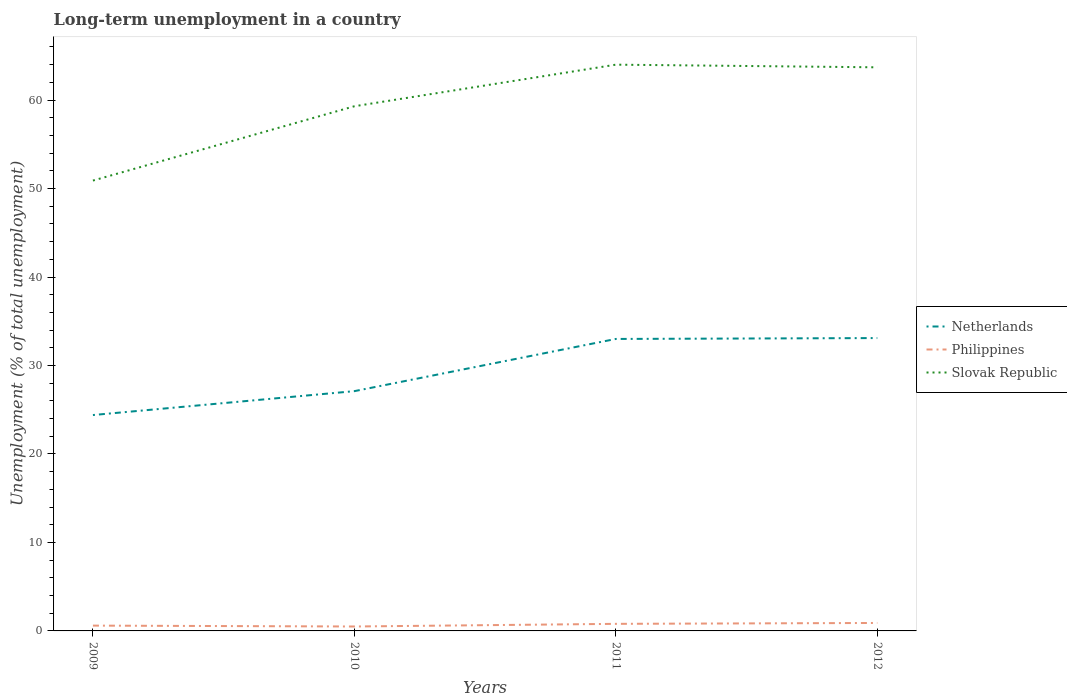How many different coloured lines are there?
Provide a succinct answer. 3. Across all years, what is the maximum percentage of long-term unemployed population in Philippines?
Your response must be concise. 0.5. In which year was the percentage of long-term unemployed population in Slovak Republic maximum?
Keep it short and to the point. 2009. What is the total percentage of long-term unemployed population in Netherlands in the graph?
Ensure brevity in your answer.  -0.1. What is the difference between the highest and the second highest percentage of long-term unemployed population in Philippines?
Your response must be concise. 0.4. How many lines are there?
Provide a short and direct response. 3. How many years are there in the graph?
Offer a very short reply. 4. Are the values on the major ticks of Y-axis written in scientific E-notation?
Your answer should be very brief. No. Does the graph contain grids?
Provide a short and direct response. No. Where does the legend appear in the graph?
Keep it short and to the point. Center right. How many legend labels are there?
Provide a short and direct response. 3. What is the title of the graph?
Give a very brief answer. Long-term unemployment in a country. What is the label or title of the Y-axis?
Offer a very short reply. Unemployment (% of total unemployment). What is the Unemployment (% of total unemployment) of Netherlands in 2009?
Provide a short and direct response. 24.4. What is the Unemployment (% of total unemployment) in Philippines in 2009?
Your response must be concise. 0.6. What is the Unemployment (% of total unemployment) of Slovak Republic in 2009?
Provide a short and direct response. 50.9. What is the Unemployment (% of total unemployment) in Netherlands in 2010?
Your response must be concise. 27.1. What is the Unemployment (% of total unemployment) in Slovak Republic in 2010?
Your answer should be very brief. 59.3. What is the Unemployment (% of total unemployment) of Netherlands in 2011?
Ensure brevity in your answer.  33. What is the Unemployment (% of total unemployment) in Philippines in 2011?
Provide a short and direct response. 0.8. What is the Unemployment (% of total unemployment) in Netherlands in 2012?
Your response must be concise. 33.1. What is the Unemployment (% of total unemployment) in Philippines in 2012?
Offer a terse response. 0.9. What is the Unemployment (% of total unemployment) in Slovak Republic in 2012?
Make the answer very short. 63.7. Across all years, what is the maximum Unemployment (% of total unemployment) of Netherlands?
Provide a succinct answer. 33.1. Across all years, what is the maximum Unemployment (% of total unemployment) of Philippines?
Your response must be concise. 0.9. Across all years, what is the maximum Unemployment (% of total unemployment) in Slovak Republic?
Ensure brevity in your answer.  64. Across all years, what is the minimum Unemployment (% of total unemployment) in Netherlands?
Make the answer very short. 24.4. Across all years, what is the minimum Unemployment (% of total unemployment) of Philippines?
Give a very brief answer. 0.5. Across all years, what is the minimum Unemployment (% of total unemployment) in Slovak Republic?
Ensure brevity in your answer.  50.9. What is the total Unemployment (% of total unemployment) of Netherlands in the graph?
Keep it short and to the point. 117.6. What is the total Unemployment (% of total unemployment) of Philippines in the graph?
Your response must be concise. 2.8. What is the total Unemployment (% of total unemployment) of Slovak Republic in the graph?
Your response must be concise. 237.9. What is the difference between the Unemployment (% of total unemployment) in Netherlands in 2009 and that in 2010?
Offer a terse response. -2.7. What is the difference between the Unemployment (% of total unemployment) in Philippines in 2009 and that in 2011?
Give a very brief answer. -0.2. What is the difference between the Unemployment (% of total unemployment) in Netherlands in 2009 and that in 2012?
Give a very brief answer. -8.7. What is the difference between the Unemployment (% of total unemployment) of Philippines in 2009 and that in 2012?
Provide a short and direct response. -0.3. What is the difference between the Unemployment (% of total unemployment) in Netherlands in 2010 and that in 2011?
Keep it short and to the point. -5.9. What is the difference between the Unemployment (% of total unemployment) in Philippines in 2010 and that in 2011?
Give a very brief answer. -0.3. What is the difference between the Unemployment (% of total unemployment) in Netherlands in 2010 and that in 2012?
Provide a short and direct response. -6. What is the difference between the Unemployment (% of total unemployment) in Netherlands in 2011 and that in 2012?
Offer a terse response. -0.1. What is the difference between the Unemployment (% of total unemployment) of Slovak Republic in 2011 and that in 2012?
Your response must be concise. 0.3. What is the difference between the Unemployment (% of total unemployment) of Netherlands in 2009 and the Unemployment (% of total unemployment) of Philippines in 2010?
Make the answer very short. 23.9. What is the difference between the Unemployment (% of total unemployment) in Netherlands in 2009 and the Unemployment (% of total unemployment) in Slovak Republic in 2010?
Provide a short and direct response. -34.9. What is the difference between the Unemployment (% of total unemployment) in Philippines in 2009 and the Unemployment (% of total unemployment) in Slovak Republic in 2010?
Make the answer very short. -58.7. What is the difference between the Unemployment (% of total unemployment) in Netherlands in 2009 and the Unemployment (% of total unemployment) in Philippines in 2011?
Your answer should be compact. 23.6. What is the difference between the Unemployment (% of total unemployment) in Netherlands in 2009 and the Unemployment (% of total unemployment) in Slovak Republic in 2011?
Your answer should be compact. -39.6. What is the difference between the Unemployment (% of total unemployment) in Philippines in 2009 and the Unemployment (% of total unemployment) in Slovak Republic in 2011?
Provide a succinct answer. -63.4. What is the difference between the Unemployment (% of total unemployment) in Netherlands in 2009 and the Unemployment (% of total unemployment) in Slovak Republic in 2012?
Offer a very short reply. -39.3. What is the difference between the Unemployment (% of total unemployment) of Philippines in 2009 and the Unemployment (% of total unemployment) of Slovak Republic in 2012?
Ensure brevity in your answer.  -63.1. What is the difference between the Unemployment (% of total unemployment) in Netherlands in 2010 and the Unemployment (% of total unemployment) in Philippines in 2011?
Keep it short and to the point. 26.3. What is the difference between the Unemployment (% of total unemployment) in Netherlands in 2010 and the Unemployment (% of total unemployment) in Slovak Republic in 2011?
Offer a terse response. -36.9. What is the difference between the Unemployment (% of total unemployment) in Philippines in 2010 and the Unemployment (% of total unemployment) in Slovak Republic in 2011?
Make the answer very short. -63.5. What is the difference between the Unemployment (% of total unemployment) in Netherlands in 2010 and the Unemployment (% of total unemployment) in Philippines in 2012?
Your answer should be compact. 26.2. What is the difference between the Unemployment (% of total unemployment) in Netherlands in 2010 and the Unemployment (% of total unemployment) in Slovak Republic in 2012?
Ensure brevity in your answer.  -36.6. What is the difference between the Unemployment (% of total unemployment) in Philippines in 2010 and the Unemployment (% of total unemployment) in Slovak Republic in 2012?
Provide a short and direct response. -63.2. What is the difference between the Unemployment (% of total unemployment) in Netherlands in 2011 and the Unemployment (% of total unemployment) in Philippines in 2012?
Your answer should be very brief. 32.1. What is the difference between the Unemployment (% of total unemployment) of Netherlands in 2011 and the Unemployment (% of total unemployment) of Slovak Republic in 2012?
Provide a succinct answer. -30.7. What is the difference between the Unemployment (% of total unemployment) in Philippines in 2011 and the Unemployment (% of total unemployment) in Slovak Republic in 2012?
Your answer should be compact. -62.9. What is the average Unemployment (% of total unemployment) in Netherlands per year?
Your answer should be very brief. 29.4. What is the average Unemployment (% of total unemployment) in Philippines per year?
Make the answer very short. 0.7. What is the average Unemployment (% of total unemployment) of Slovak Republic per year?
Provide a short and direct response. 59.48. In the year 2009, what is the difference between the Unemployment (% of total unemployment) in Netherlands and Unemployment (% of total unemployment) in Philippines?
Ensure brevity in your answer.  23.8. In the year 2009, what is the difference between the Unemployment (% of total unemployment) in Netherlands and Unemployment (% of total unemployment) in Slovak Republic?
Offer a very short reply. -26.5. In the year 2009, what is the difference between the Unemployment (% of total unemployment) of Philippines and Unemployment (% of total unemployment) of Slovak Republic?
Your response must be concise. -50.3. In the year 2010, what is the difference between the Unemployment (% of total unemployment) of Netherlands and Unemployment (% of total unemployment) of Philippines?
Provide a succinct answer. 26.6. In the year 2010, what is the difference between the Unemployment (% of total unemployment) in Netherlands and Unemployment (% of total unemployment) in Slovak Republic?
Your answer should be compact. -32.2. In the year 2010, what is the difference between the Unemployment (% of total unemployment) of Philippines and Unemployment (% of total unemployment) of Slovak Republic?
Your answer should be compact. -58.8. In the year 2011, what is the difference between the Unemployment (% of total unemployment) in Netherlands and Unemployment (% of total unemployment) in Philippines?
Your answer should be very brief. 32.2. In the year 2011, what is the difference between the Unemployment (% of total unemployment) in Netherlands and Unemployment (% of total unemployment) in Slovak Republic?
Give a very brief answer. -31. In the year 2011, what is the difference between the Unemployment (% of total unemployment) of Philippines and Unemployment (% of total unemployment) of Slovak Republic?
Your answer should be compact. -63.2. In the year 2012, what is the difference between the Unemployment (% of total unemployment) of Netherlands and Unemployment (% of total unemployment) of Philippines?
Provide a short and direct response. 32.2. In the year 2012, what is the difference between the Unemployment (% of total unemployment) in Netherlands and Unemployment (% of total unemployment) in Slovak Republic?
Your response must be concise. -30.6. In the year 2012, what is the difference between the Unemployment (% of total unemployment) of Philippines and Unemployment (% of total unemployment) of Slovak Republic?
Provide a succinct answer. -62.8. What is the ratio of the Unemployment (% of total unemployment) of Netherlands in 2009 to that in 2010?
Give a very brief answer. 0.9. What is the ratio of the Unemployment (% of total unemployment) in Slovak Republic in 2009 to that in 2010?
Ensure brevity in your answer.  0.86. What is the ratio of the Unemployment (% of total unemployment) in Netherlands in 2009 to that in 2011?
Provide a succinct answer. 0.74. What is the ratio of the Unemployment (% of total unemployment) in Philippines in 2009 to that in 2011?
Offer a very short reply. 0.75. What is the ratio of the Unemployment (% of total unemployment) in Slovak Republic in 2009 to that in 2011?
Your answer should be compact. 0.8. What is the ratio of the Unemployment (% of total unemployment) of Netherlands in 2009 to that in 2012?
Make the answer very short. 0.74. What is the ratio of the Unemployment (% of total unemployment) in Philippines in 2009 to that in 2012?
Offer a terse response. 0.67. What is the ratio of the Unemployment (% of total unemployment) in Slovak Republic in 2009 to that in 2012?
Give a very brief answer. 0.8. What is the ratio of the Unemployment (% of total unemployment) in Netherlands in 2010 to that in 2011?
Keep it short and to the point. 0.82. What is the ratio of the Unemployment (% of total unemployment) in Philippines in 2010 to that in 2011?
Offer a terse response. 0.62. What is the ratio of the Unemployment (% of total unemployment) of Slovak Republic in 2010 to that in 2011?
Make the answer very short. 0.93. What is the ratio of the Unemployment (% of total unemployment) in Netherlands in 2010 to that in 2012?
Provide a short and direct response. 0.82. What is the ratio of the Unemployment (% of total unemployment) in Philippines in 2010 to that in 2012?
Keep it short and to the point. 0.56. What is the ratio of the Unemployment (% of total unemployment) in Slovak Republic in 2010 to that in 2012?
Ensure brevity in your answer.  0.93. What is the ratio of the Unemployment (% of total unemployment) of Philippines in 2011 to that in 2012?
Make the answer very short. 0.89. What is the difference between the highest and the second highest Unemployment (% of total unemployment) in Netherlands?
Provide a succinct answer. 0.1. What is the difference between the highest and the second highest Unemployment (% of total unemployment) of Philippines?
Offer a terse response. 0.1. What is the difference between the highest and the second highest Unemployment (% of total unemployment) in Slovak Republic?
Your response must be concise. 0.3. What is the difference between the highest and the lowest Unemployment (% of total unemployment) in Slovak Republic?
Provide a succinct answer. 13.1. 